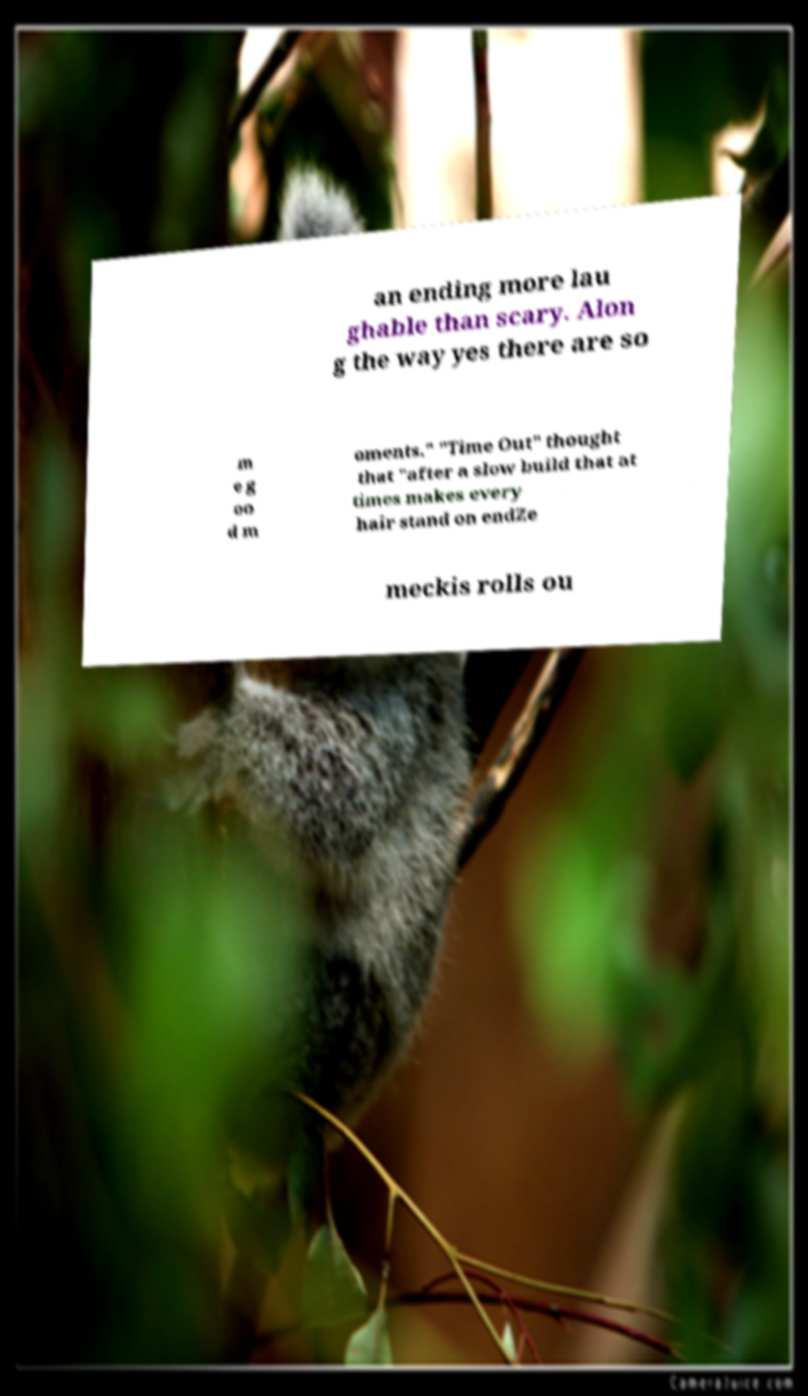Can you accurately transcribe the text from the provided image for me? an ending more lau ghable than scary. Alon g the way yes there are so m e g oo d m oments." "Time Out" thought that "after a slow build that at times makes every hair stand on endZe meckis rolls ou 